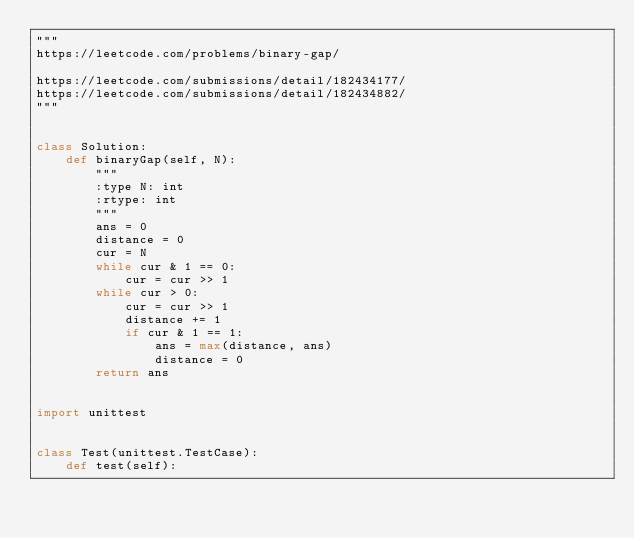Convert code to text. <code><loc_0><loc_0><loc_500><loc_500><_Python_>"""
https://leetcode.com/problems/binary-gap/

https://leetcode.com/submissions/detail/182434177/
https://leetcode.com/submissions/detail/182434882/
"""


class Solution:
    def binaryGap(self, N):
        """
        :type N: int
        :rtype: int
        """
        ans = 0
        distance = 0
        cur = N
        while cur & 1 == 0:
            cur = cur >> 1
        while cur > 0:
            cur = cur >> 1
            distance += 1
            if cur & 1 == 1:
                ans = max(distance, ans)
                distance = 0
        return ans


import unittest


class Test(unittest.TestCase):
    def test(self):</code> 